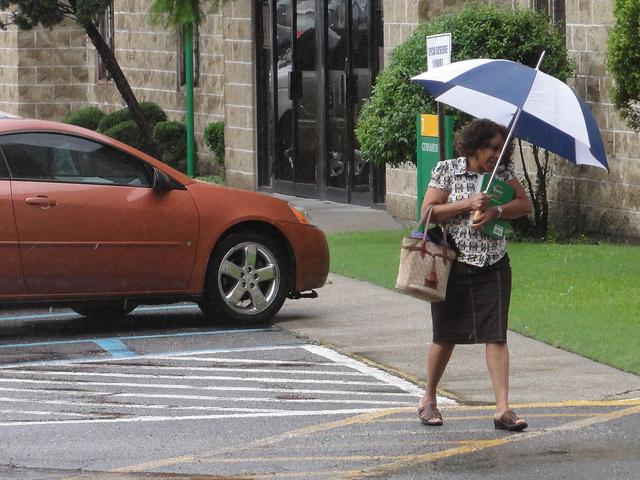What two primary colors have to be combined to get the color of the car?

Choices:
A) blueyellow
B) redyellow
C) redblue
D) redwhite redyellow 